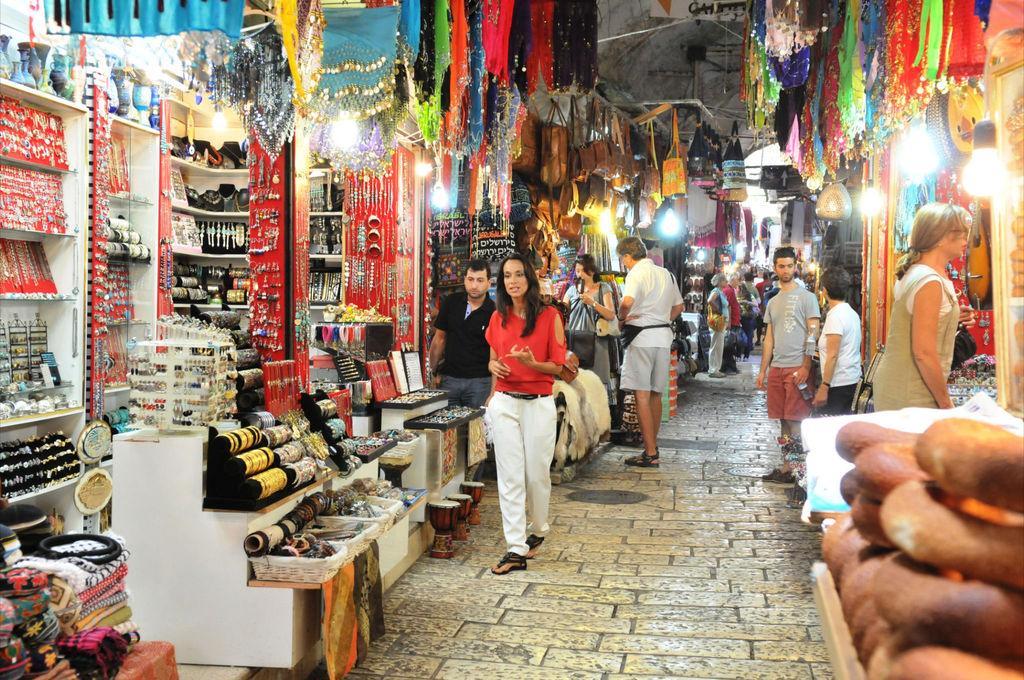How would you summarize this image in a sentence or two? In the foreground of this picture, there are buns on the right bottom corner. In the background, there are persons standing on the path and there are few stalls. On the left there is a ladies emporium stall. In the background, there are bags, lights and persons standing. 